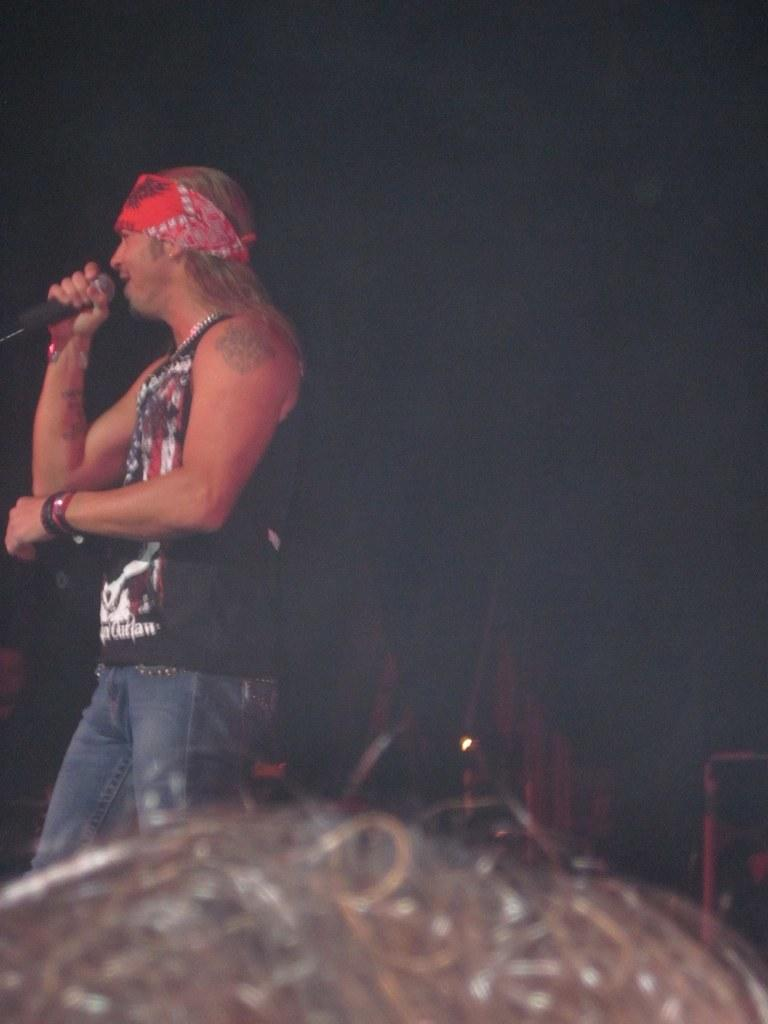What is the main subject of the image? There is a person in the image. What is the person holding in the image? The person is holding a microphone. Can you describe the background of the image? The background of the image is dark. What type of quartz can be seen in the person's hand in the image? There is no quartz present in the image; the person is holding a microphone. 